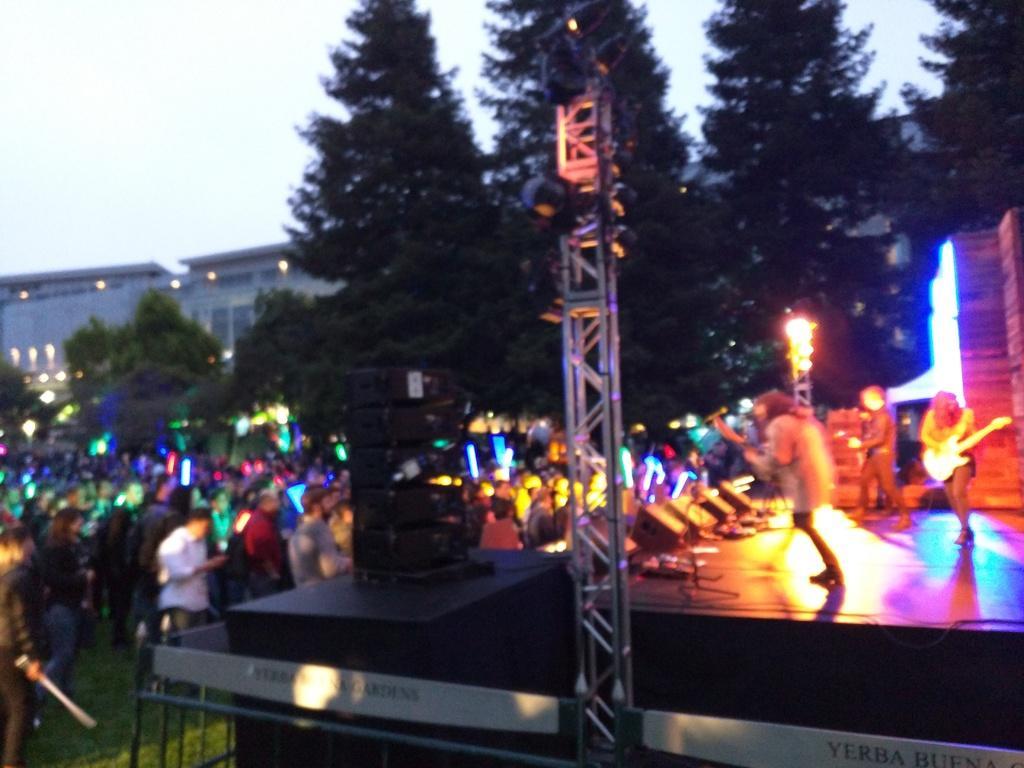Can you describe this image briefly? In this picture we can see there are three persons standing on the stage and a person is holding a guitar. On the left side of the image, there is a group of people standing. Behind the people, there are trees, buildings and the sky. There are trusses with lights. 